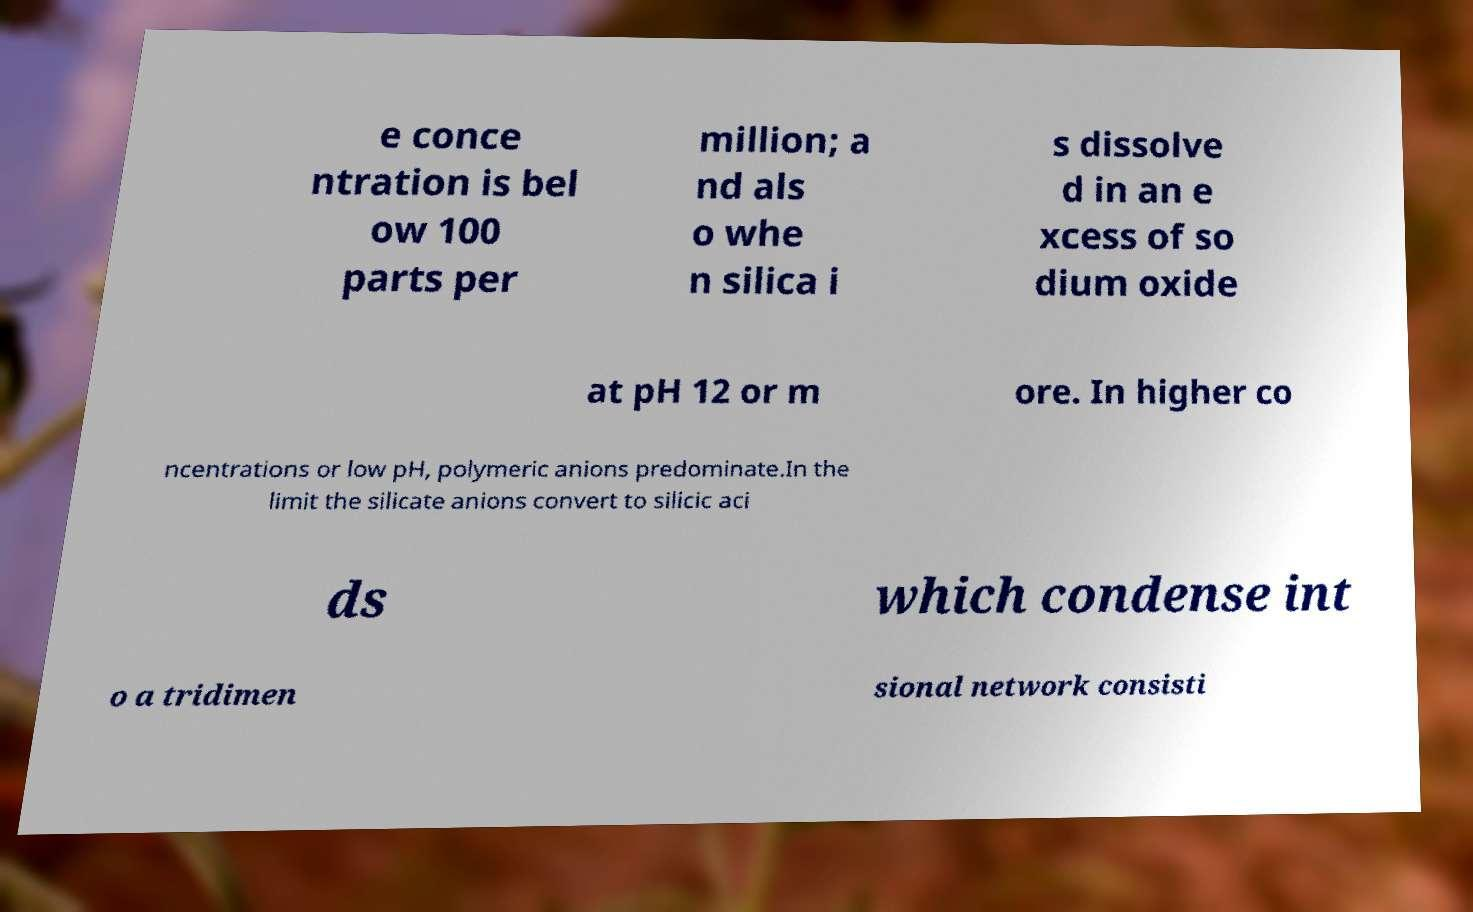Could you assist in decoding the text presented in this image and type it out clearly? e conce ntration is bel ow 100 parts per million; a nd als o whe n silica i s dissolve d in an e xcess of so dium oxide at pH 12 or m ore. In higher co ncentrations or low pH, polymeric anions predominate.In the limit the silicate anions convert to silicic aci ds which condense int o a tridimen sional network consisti 